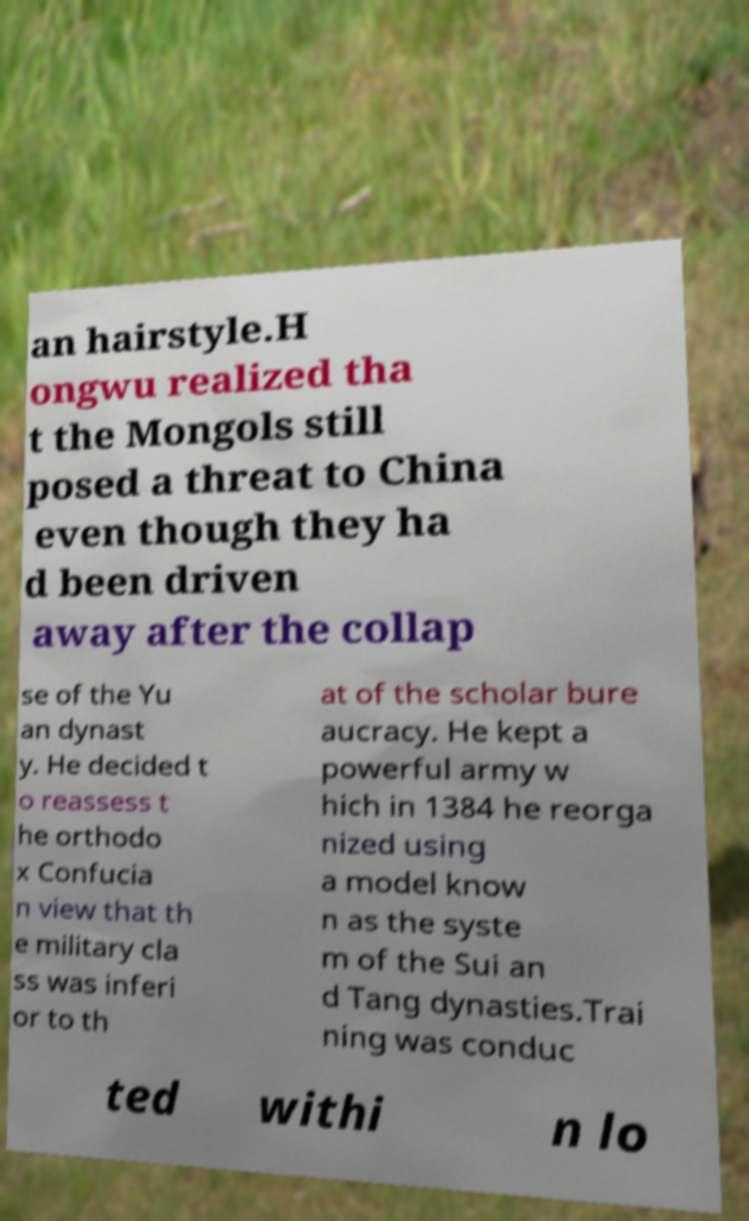There's text embedded in this image that I need extracted. Can you transcribe it verbatim? an hairstyle.H ongwu realized tha t the Mongols still posed a threat to China even though they ha d been driven away after the collap se of the Yu an dynast y. He decided t o reassess t he orthodo x Confucia n view that th e military cla ss was inferi or to th at of the scholar bure aucracy. He kept a powerful army w hich in 1384 he reorga nized using a model know n as the syste m of the Sui an d Tang dynasties.Trai ning was conduc ted withi n lo 